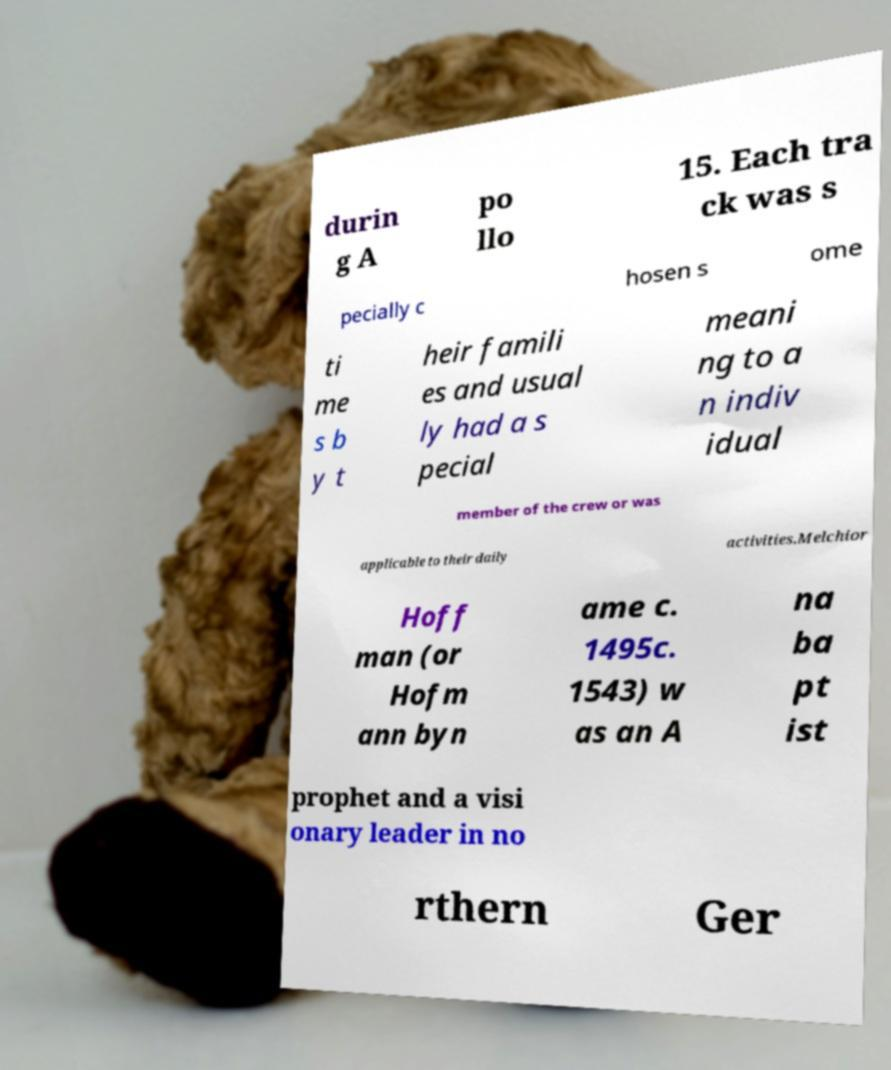Please identify and transcribe the text found in this image. durin g A po llo 15. Each tra ck was s pecially c hosen s ome ti me s b y t heir famili es and usual ly had a s pecial meani ng to a n indiv idual member of the crew or was applicable to their daily activities.Melchior Hoff man (or Hofm ann byn ame c. 1495c. 1543) w as an A na ba pt ist prophet and a visi onary leader in no rthern Ger 